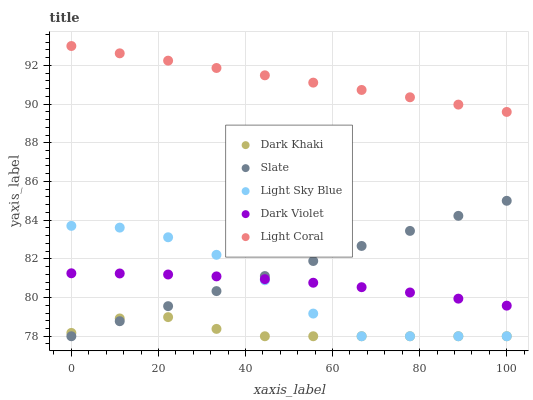Does Dark Khaki have the minimum area under the curve?
Answer yes or no. Yes. Does Light Coral have the maximum area under the curve?
Answer yes or no. Yes. Does Slate have the minimum area under the curve?
Answer yes or no. No. Does Slate have the maximum area under the curve?
Answer yes or no. No. Is Slate the smoothest?
Answer yes or no. Yes. Is Light Sky Blue the roughest?
Answer yes or no. Yes. Is Light Coral the smoothest?
Answer yes or no. No. Is Light Coral the roughest?
Answer yes or no. No. Does Dark Khaki have the lowest value?
Answer yes or no. Yes. Does Light Coral have the lowest value?
Answer yes or no. No. Does Light Coral have the highest value?
Answer yes or no. Yes. Does Slate have the highest value?
Answer yes or no. No. Is Slate less than Light Coral?
Answer yes or no. Yes. Is Light Coral greater than Dark Violet?
Answer yes or no. Yes. Does Light Sky Blue intersect Dark Violet?
Answer yes or no. Yes. Is Light Sky Blue less than Dark Violet?
Answer yes or no. No. Is Light Sky Blue greater than Dark Violet?
Answer yes or no. No. Does Slate intersect Light Coral?
Answer yes or no. No. 